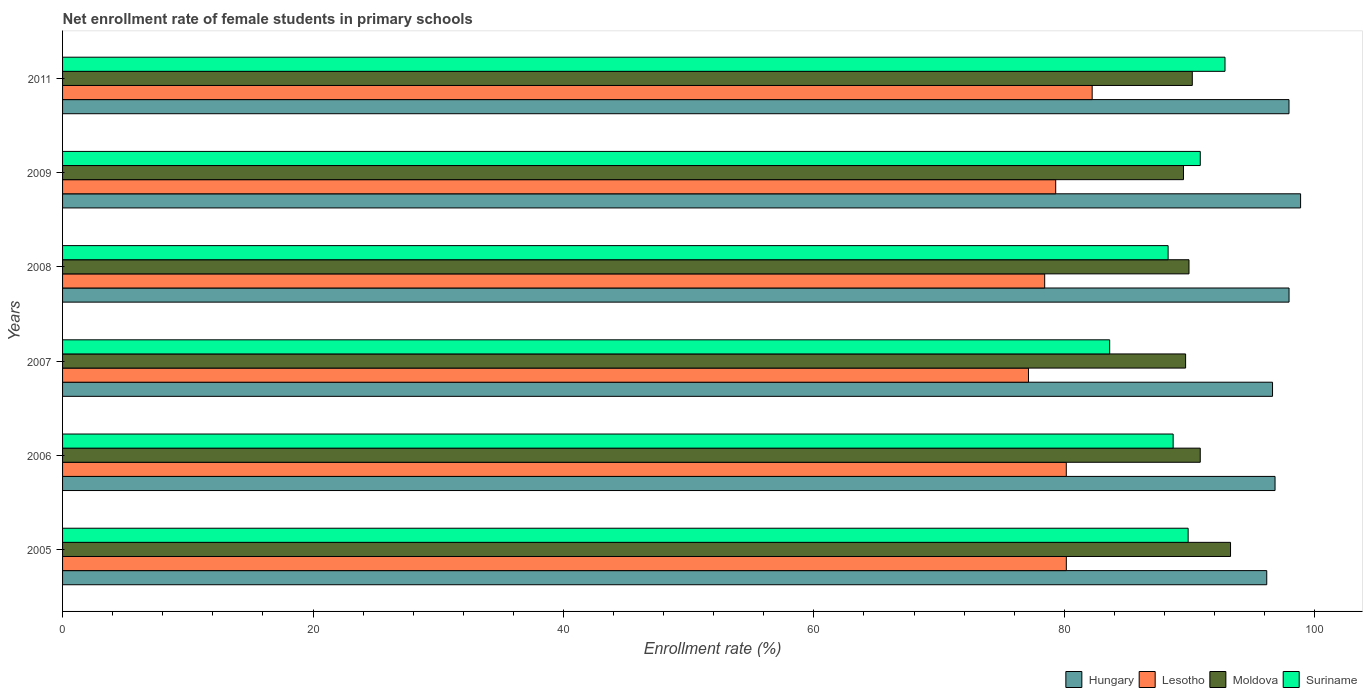Are the number of bars on each tick of the Y-axis equal?
Ensure brevity in your answer.  Yes. What is the label of the 6th group of bars from the top?
Provide a succinct answer. 2005. What is the net enrollment rate of female students in primary schools in Hungary in 2011?
Provide a succinct answer. 97.94. Across all years, what is the maximum net enrollment rate of female students in primary schools in Hungary?
Make the answer very short. 98.87. Across all years, what is the minimum net enrollment rate of female students in primary schools in Hungary?
Offer a very short reply. 96.17. What is the total net enrollment rate of female students in primary schools in Suriname in the graph?
Keep it short and to the point. 534.18. What is the difference between the net enrollment rate of female students in primary schools in Lesotho in 2008 and that in 2011?
Offer a terse response. -3.79. What is the difference between the net enrollment rate of female students in primary schools in Lesotho in 2009 and the net enrollment rate of female students in primary schools in Suriname in 2007?
Keep it short and to the point. -4.31. What is the average net enrollment rate of female students in primary schools in Moldova per year?
Offer a terse response. 90.58. In the year 2006, what is the difference between the net enrollment rate of female students in primary schools in Moldova and net enrollment rate of female students in primary schools in Suriname?
Provide a short and direct response. 2.16. What is the ratio of the net enrollment rate of female students in primary schools in Suriname in 2009 to that in 2011?
Give a very brief answer. 0.98. Is the net enrollment rate of female students in primary schools in Hungary in 2006 less than that in 2009?
Ensure brevity in your answer.  Yes. What is the difference between the highest and the second highest net enrollment rate of female students in primary schools in Lesotho?
Offer a very short reply. 2.06. What is the difference between the highest and the lowest net enrollment rate of female students in primary schools in Suriname?
Provide a succinct answer. 9.21. Is the sum of the net enrollment rate of female students in primary schools in Hungary in 2007 and 2011 greater than the maximum net enrollment rate of female students in primary schools in Lesotho across all years?
Provide a short and direct response. Yes. What does the 3rd bar from the top in 2005 represents?
Offer a terse response. Lesotho. What does the 4th bar from the bottom in 2009 represents?
Keep it short and to the point. Suriname. Is it the case that in every year, the sum of the net enrollment rate of female students in primary schools in Moldova and net enrollment rate of female students in primary schools in Hungary is greater than the net enrollment rate of female students in primary schools in Suriname?
Give a very brief answer. Yes. How many bars are there?
Your answer should be compact. 24. What is the difference between two consecutive major ticks on the X-axis?
Make the answer very short. 20. Are the values on the major ticks of X-axis written in scientific E-notation?
Offer a terse response. No. Where does the legend appear in the graph?
Provide a succinct answer. Bottom right. What is the title of the graph?
Provide a succinct answer. Net enrollment rate of female students in primary schools. What is the label or title of the X-axis?
Offer a terse response. Enrollment rate (%). What is the label or title of the Y-axis?
Keep it short and to the point. Years. What is the Enrollment rate (%) of Hungary in 2005?
Your answer should be compact. 96.17. What is the Enrollment rate (%) in Lesotho in 2005?
Ensure brevity in your answer.  80.16. What is the Enrollment rate (%) in Moldova in 2005?
Give a very brief answer. 93.27. What is the Enrollment rate (%) of Suriname in 2005?
Give a very brief answer. 89.89. What is the Enrollment rate (%) in Hungary in 2006?
Your answer should be very brief. 96.83. What is the Enrollment rate (%) of Lesotho in 2006?
Provide a short and direct response. 80.16. What is the Enrollment rate (%) in Moldova in 2006?
Your answer should be compact. 90.86. What is the Enrollment rate (%) in Suriname in 2006?
Provide a succinct answer. 88.69. What is the Enrollment rate (%) in Hungary in 2007?
Keep it short and to the point. 96.63. What is the Enrollment rate (%) in Lesotho in 2007?
Make the answer very short. 77.14. What is the Enrollment rate (%) of Moldova in 2007?
Your answer should be compact. 89.69. What is the Enrollment rate (%) of Suriname in 2007?
Ensure brevity in your answer.  83.62. What is the Enrollment rate (%) of Hungary in 2008?
Offer a terse response. 97.95. What is the Enrollment rate (%) of Lesotho in 2008?
Ensure brevity in your answer.  78.43. What is the Enrollment rate (%) in Moldova in 2008?
Ensure brevity in your answer.  89.96. What is the Enrollment rate (%) in Suriname in 2008?
Ensure brevity in your answer.  88.29. What is the Enrollment rate (%) of Hungary in 2009?
Keep it short and to the point. 98.87. What is the Enrollment rate (%) of Lesotho in 2009?
Ensure brevity in your answer.  79.31. What is the Enrollment rate (%) in Moldova in 2009?
Your answer should be very brief. 89.52. What is the Enrollment rate (%) of Suriname in 2009?
Keep it short and to the point. 90.86. What is the Enrollment rate (%) of Hungary in 2011?
Offer a very short reply. 97.94. What is the Enrollment rate (%) in Lesotho in 2011?
Your response must be concise. 82.22. What is the Enrollment rate (%) in Moldova in 2011?
Your response must be concise. 90.22. What is the Enrollment rate (%) of Suriname in 2011?
Keep it short and to the point. 92.83. Across all years, what is the maximum Enrollment rate (%) in Hungary?
Your answer should be compact. 98.87. Across all years, what is the maximum Enrollment rate (%) in Lesotho?
Make the answer very short. 82.22. Across all years, what is the maximum Enrollment rate (%) in Moldova?
Your answer should be very brief. 93.27. Across all years, what is the maximum Enrollment rate (%) of Suriname?
Give a very brief answer. 92.83. Across all years, what is the minimum Enrollment rate (%) of Hungary?
Ensure brevity in your answer.  96.17. Across all years, what is the minimum Enrollment rate (%) in Lesotho?
Provide a succinct answer. 77.14. Across all years, what is the minimum Enrollment rate (%) of Moldova?
Offer a terse response. 89.52. Across all years, what is the minimum Enrollment rate (%) of Suriname?
Offer a very short reply. 83.62. What is the total Enrollment rate (%) of Hungary in the graph?
Provide a succinct answer. 584.38. What is the total Enrollment rate (%) in Lesotho in the graph?
Make the answer very short. 477.42. What is the total Enrollment rate (%) of Moldova in the graph?
Offer a very short reply. 543.51. What is the total Enrollment rate (%) of Suriname in the graph?
Your answer should be very brief. 534.18. What is the difference between the Enrollment rate (%) in Hungary in 2005 and that in 2006?
Your response must be concise. -0.66. What is the difference between the Enrollment rate (%) of Lesotho in 2005 and that in 2006?
Your answer should be compact. 0. What is the difference between the Enrollment rate (%) of Moldova in 2005 and that in 2006?
Offer a terse response. 2.42. What is the difference between the Enrollment rate (%) in Suriname in 2005 and that in 2006?
Offer a terse response. 1.2. What is the difference between the Enrollment rate (%) in Hungary in 2005 and that in 2007?
Ensure brevity in your answer.  -0.46. What is the difference between the Enrollment rate (%) of Lesotho in 2005 and that in 2007?
Your answer should be very brief. 3.02. What is the difference between the Enrollment rate (%) of Moldova in 2005 and that in 2007?
Keep it short and to the point. 3.59. What is the difference between the Enrollment rate (%) in Suriname in 2005 and that in 2007?
Provide a short and direct response. 6.27. What is the difference between the Enrollment rate (%) of Hungary in 2005 and that in 2008?
Offer a terse response. -1.78. What is the difference between the Enrollment rate (%) of Lesotho in 2005 and that in 2008?
Your response must be concise. 1.73. What is the difference between the Enrollment rate (%) in Moldova in 2005 and that in 2008?
Your answer should be compact. 3.32. What is the difference between the Enrollment rate (%) of Suriname in 2005 and that in 2008?
Offer a terse response. 1.6. What is the difference between the Enrollment rate (%) of Hungary in 2005 and that in 2009?
Offer a very short reply. -2.7. What is the difference between the Enrollment rate (%) of Lesotho in 2005 and that in 2009?
Keep it short and to the point. 0.85. What is the difference between the Enrollment rate (%) of Moldova in 2005 and that in 2009?
Ensure brevity in your answer.  3.76. What is the difference between the Enrollment rate (%) of Suriname in 2005 and that in 2009?
Keep it short and to the point. -0.97. What is the difference between the Enrollment rate (%) of Hungary in 2005 and that in 2011?
Ensure brevity in your answer.  -1.78. What is the difference between the Enrollment rate (%) in Lesotho in 2005 and that in 2011?
Make the answer very short. -2.06. What is the difference between the Enrollment rate (%) in Moldova in 2005 and that in 2011?
Give a very brief answer. 3.05. What is the difference between the Enrollment rate (%) of Suriname in 2005 and that in 2011?
Provide a short and direct response. -2.94. What is the difference between the Enrollment rate (%) in Hungary in 2006 and that in 2007?
Provide a short and direct response. 0.2. What is the difference between the Enrollment rate (%) in Lesotho in 2006 and that in 2007?
Your response must be concise. 3.02. What is the difference between the Enrollment rate (%) of Moldova in 2006 and that in 2007?
Offer a terse response. 1.17. What is the difference between the Enrollment rate (%) of Suriname in 2006 and that in 2007?
Keep it short and to the point. 5.07. What is the difference between the Enrollment rate (%) in Hungary in 2006 and that in 2008?
Offer a very short reply. -1.12. What is the difference between the Enrollment rate (%) of Lesotho in 2006 and that in 2008?
Your answer should be very brief. 1.73. What is the difference between the Enrollment rate (%) in Moldova in 2006 and that in 2008?
Provide a short and direct response. 0.9. What is the difference between the Enrollment rate (%) of Suriname in 2006 and that in 2008?
Give a very brief answer. 0.4. What is the difference between the Enrollment rate (%) in Hungary in 2006 and that in 2009?
Your response must be concise. -2.04. What is the difference between the Enrollment rate (%) of Lesotho in 2006 and that in 2009?
Offer a terse response. 0.85. What is the difference between the Enrollment rate (%) of Moldova in 2006 and that in 2009?
Give a very brief answer. 1.34. What is the difference between the Enrollment rate (%) of Suriname in 2006 and that in 2009?
Make the answer very short. -2.17. What is the difference between the Enrollment rate (%) of Hungary in 2006 and that in 2011?
Give a very brief answer. -1.11. What is the difference between the Enrollment rate (%) of Lesotho in 2006 and that in 2011?
Make the answer very short. -2.07. What is the difference between the Enrollment rate (%) of Moldova in 2006 and that in 2011?
Your response must be concise. 0.64. What is the difference between the Enrollment rate (%) in Suriname in 2006 and that in 2011?
Make the answer very short. -4.14. What is the difference between the Enrollment rate (%) of Hungary in 2007 and that in 2008?
Keep it short and to the point. -1.32. What is the difference between the Enrollment rate (%) in Lesotho in 2007 and that in 2008?
Offer a very short reply. -1.29. What is the difference between the Enrollment rate (%) in Moldova in 2007 and that in 2008?
Your answer should be very brief. -0.27. What is the difference between the Enrollment rate (%) of Suriname in 2007 and that in 2008?
Make the answer very short. -4.67. What is the difference between the Enrollment rate (%) in Hungary in 2007 and that in 2009?
Your answer should be compact. -2.24. What is the difference between the Enrollment rate (%) in Lesotho in 2007 and that in 2009?
Your response must be concise. -2.17. What is the difference between the Enrollment rate (%) in Moldova in 2007 and that in 2009?
Provide a short and direct response. 0.17. What is the difference between the Enrollment rate (%) of Suriname in 2007 and that in 2009?
Provide a succinct answer. -7.24. What is the difference between the Enrollment rate (%) in Hungary in 2007 and that in 2011?
Offer a terse response. -1.32. What is the difference between the Enrollment rate (%) in Lesotho in 2007 and that in 2011?
Make the answer very short. -5.09. What is the difference between the Enrollment rate (%) of Moldova in 2007 and that in 2011?
Your answer should be compact. -0.53. What is the difference between the Enrollment rate (%) in Suriname in 2007 and that in 2011?
Your answer should be very brief. -9.21. What is the difference between the Enrollment rate (%) in Hungary in 2008 and that in 2009?
Provide a short and direct response. -0.92. What is the difference between the Enrollment rate (%) of Lesotho in 2008 and that in 2009?
Offer a terse response. -0.88. What is the difference between the Enrollment rate (%) in Moldova in 2008 and that in 2009?
Offer a terse response. 0.44. What is the difference between the Enrollment rate (%) of Suriname in 2008 and that in 2009?
Your answer should be compact. -2.57. What is the difference between the Enrollment rate (%) of Hungary in 2008 and that in 2011?
Provide a succinct answer. 0. What is the difference between the Enrollment rate (%) of Lesotho in 2008 and that in 2011?
Your answer should be very brief. -3.79. What is the difference between the Enrollment rate (%) in Moldova in 2008 and that in 2011?
Your answer should be compact. -0.26. What is the difference between the Enrollment rate (%) in Suriname in 2008 and that in 2011?
Provide a succinct answer. -4.54. What is the difference between the Enrollment rate (%) of Hungary in 2009 and that in 2011?
Offer a terse response. 0.93. What is the difference between the Enrollment rate (%) of Lesotho in 2009 and that in 2011?
Provide a succinct answer. -2.91. What is the difference between the Enrollment rate (%) of Moldova in 2009 and that in 2011?
Ensure brevity in your answer.  -0.7. What is the difference between the Enrollment rate (%) in Suriname in 2009 and that in 2011?
Ensure brevity in your answer.  -1.98. What is the difference between the Enrollment rate (%) in Hungary in 2005 and the Enrollment rate (%) in Lesotho in 2006?
Your answer should be very brief. 16.01. What is the difference between the Enrollment rate (%) of Hungary in 2005 and the Enrollment rate (%) of Moldova in 2006?
Keep it short and to the point. 5.31. What is the difference between the Enrollment rate (%) in Hungary in 2005 and the Enrollment rate (%) in Suriname in 2006?
Provide a short and direct response. 7.48. What is the difference between the Enrollment rate (%) in Lesotho in 2005 and the Enrollment rate (%) in Moldova in 2006?
Your response must be concise. -10.69. What is the difference between the Enrollment rate (%) of Lesotho in 2005 and the Enrollment rate (%) of Suriname in 2006?
Your answer should be very brief. -8.53. What is the difference between the Enrollment rate (%) in Moldova in 2005 and the Enrollment rate (%) in Suriname in 2006?
Your answer should be compact. 4.58. What is the difference between the Enrollment rate (%) in Hungary in 2005 and the Enrollment rate (%) in Lesotho in 2007?
Your answer should be very brief. 19.03. What is the difference between the Enrollment rate (%) of Hungary in 2005 and the Enrollment rate (%) of Moldova in 2007?
Your response must be concise. 6.48. What is the difference between the Enrollment rate (%) in Hungary in 2005 and the Enrollment rate (%) in Suriname in 2007?
Offer a terse response. 12.55. What is the difference between the Enrollment rate (%) in Lesotho in 2005 and the Enrollment rate (%) in Moldova in 2007?
Provide a short and direct response. -9.53. What is the difference between the Enrollment rate (%) of Lesotho in 2005 and the Enrollment rate (%) of Suriname in 2007?
Keep it short and to the point. -3.46. What is the difference between the Enrollment rate (%) of Moldova in 2005 and the Enrollment rate (%) of Suriname in 2007?
Give a very brief answer. 9.65. What is the difference between the Enrollment rate (%) in Hungary in 2005 and the Enrollment rate (%) in Lesotho in 2008?
Your response must be concise. 17.73. What is the difference between the Enrollment rate (%) of Hungary in 2005 and the Enrollment rate (%) of Moldova in 2008?
Provide a short and direct response. 6.21. What is the difference between the Enrollment rate (%) of Hungary in 2005 and the Enrollment rate (%) of Suriname in 2008?
Provide a succinct answer. 7.88. What is the difference between the Enrollment rate (%) in Lesotho in 2005 and the Enrollment rate (%) in Moldova in 2008?
Keep it short and to the point. -9.8. What is the difference between the Enrollment rate (%) of Lesotho in 2005 and the Enrollment rate (%) of Suriname in 2008?
Keep it short and to the point. -8.13. What is the difference between the Enrollment rate (%) of Moldova in 2005 and the Enrollment rate (%) of Suriname in 2008?
Offer a terse response. 4.99. What is the difference between the Enrollment rate (%) in Hungary in 2005 and the Enrollment rate (%) in Lesotho in 2009?
Offer a terse response. 16.85. What is the difference between the Enrollment rate (%) in Hungary in 2005 and the Enrollment rate (%) in Moldova in 2009?
Provide a succinct answer. 6.65. What is the difference between the Enrollment rate (%) of Hungary in 2005 and the Enrollment rate (%) of Suriname in 2009?
Keep it short and to the point. 5.31. What is the difference between the Enrollment rate (%) in Lesotho in 2005 and the Enrollment rate (%) in Moldova in 2009?
Your answer should be very brief. -9.36. What is the difference between the Enrollment rate (%) in Lesotho in 2005 and the Enrollment rate (%) in Suriname in 2009?
Your answer should be compact. -10.7. What is the difference between the Enrollment rate (%) in Moldova in 2005 and the Enrollment rate (%) in Suriname in 2009?
Your answer should be compact. 2.42. What is the difference between the Enrollment rate (%) in Hungary in 2005 and the Enrollment rate (%) in Lesotho in 2011?
Your answer should be very brief. 13.94. What is the difference between the Enrollment rate (%) in Hungary in 2005 and the Enrollment rate (%) in Moldova in 2011?
Ensure brevity in your answer.  5.95. What is the difference between the Enrollment rate (%) of Hungary in 2005 and the Enrollment rate (%) of Suriname in 2011?
Offer a very short reply. 3.33. What is the difference between the Enrollment rate (%) in Lesotho in 2005 and the Enrollment rate (%) in Moldova in 2011?
Your answer should be compact. -10.06. What is the difference between the Enrollment rate (%) in Lesotho in 2005 and the Enrollment rate (%) in Suriname in 2011?
Provide a succinct answer. -12.67. What is the difference between the Enrollment rate (%) of Moldova in 2005 and the Enrollment rate (%) of Suriname in 2011?
Offer a very short reply. 0.44. What is the difference between the Enrollment rate (%) of Hungary in 2006 and the Enrollment rate (%) of Lesotho in 2007?
Provide a short and direct response. 19.69. What is the difference between the Enrollment rate (%) of Hungary in 2006 and the Enrollment rate (%) of Moldova in 2007?
Your answer should be very brief. 7.14. What is the difference between the Enrollment rate (%) in Hungary in 2006 and the Enrollment rate (%) in Suriname in 2007?
Offer a very short reply. 13.21. What is the difference between the Enrollment rate (%) of Lesotho in 2006 and the Enrollment rate (%) of Moldova in 2007?
Offer a terse response. -9.53. What is the difference between the Enrollment rate (%) in Lesotho in 2006 and the Enrollment rate (%) in Suriname in 2007?
Keep it short and to the point. -3.46. What is the difference between the Enrollment rate (%) in Moldova in 2006 and the Enrollment rate (%) in Suriname in 2007?
Give a very brief answer. 7.23. What is the difference between the Enrollment rate (%) in Hungary in 2006 and the Enrollment rate (%) in Lesotho in 2008?
Provide a short and direct response. 18.4. What is the difference between the Enrollment rate (%) of Hungary in 2006 and the Enrollment rate (%) of Moldova in 2008?
Your response must be concise. 6.87. What is the difference between the Enrollment rate (%) in Hungary in 2006 and the Enrollment rate (%) in Suriname in 2008?
Offer a very short reply. 8.54. What is the difference between the Enrollment rate (%) of Lesotho in 2006 and the Enrollment rate (%) of Moldova in 2008?
Your answer should be compact. -9.8. What is the difference between the Enrollment rate (%) of Lesotho in 2006 and the Enrollment rate (%) of Suriname in 2008?
Give a very brief answer. -8.13. What is the difference between the Enrollment rate (%) of Moldova in 2006 and the Enrollment rate (%) of Suriname in 2008?
Keep it short and to the point. 2.57. What is the difference between the Enrollment rate (%) in Hungary in 2006 and the Enrollment rate (%) in Lesotho in 2009?
Provide a succinct answer. 17.52. What is the difference between the Enrollment rate (%) of Hungary in 2006 and the Enrollment rate (%) of Moldova in 2009?
Ensure brevity in your answer.  7.31. What is the difference between the Enrollment rate (%) in Hungary in 2006 and the Enrollment rate (%) in Suriname in 2009?
Give a very brief answer. 5.97. What is the difference between the Enrollment rate (%) in Lesotho in 2006 and the Enrollment rate (%) in Moldova in 2009?
Ensure brevity in your answer.  -9.36. What is the difference between the Enrollment rate (%) of Lesotho in 2006 and the Enrollment rate (%) of Suriname in 2009?
Provide a succinct answer. -10.7. What is the difference between the Enrollment rate (%) in Moldova in 2006 and the Enrollment rate (%) in Suriname in 2009?
Offer a terse response. -0. What is the difference between the Enrollment rate (%) of Hungary in 2006 and the Enrollment rate (%) of Lesotho in 2011?
Your answer should be very brief. 14.6. What is the difference between the Enrollment rate (%) of Hungary in 2006 and the Enrollment rate (%) of Moldova in 2011?
Give a very brief answer. 6.61. What is the difference between the Enrollment rate (%) of Hungary in 2006 and the Enrollment rate (%) of Suriname in 2011?
Offer a very short reply. 4. What is the difference between the Enrollment rate (%) in Lesotho in 2006 and the Enrollment rate (%) in Moldova in 2011?
Offer a terse response. -10.06. What is the difference between the Enrollment rate (%) of Lesotho in 2006 and the Enrollment rate (%) of Suriname in 2011?
Offer a very short reply. -12.67. What is the difference between the Enrollment rate (%) of Moldova in 2006 and the Enrollment rate (%) of Suriname in 2011?
Offer a terse response. -1.98. What is the difference between the Enrollment rate (%) in Hungary in 2007 and the Enrollment rate (%) in Lesotho in 2008?
Your response must be concise. 18.2. What is the difference between the Enrollment rate (%) in Hungary in 2007 and the Enrollment rate (%) in Moldova in 2008?
Your answer should be compact. 6.67. What is the difference between the Enrollment rate (%) of Hungary in 2007 and the Enrollment rate (%) of Suriname in 2008?
Your response must be concise. 8.34. What is the difference between the Enrollment rate (%) in Lesotho in 2007 and the Enrollment rate (%) in Moldova in 2008?
Your answer should be very brief. -12.82. What is the difference between the Enrollment rate (%) in Lesotho in 2007 and the Enrollment rate (%) in Suriname in 2008?
Make the answer very short. -11.15. What is the difference between the Enrollment rate (%) of Moldova in 2007 and the Enrollment rate (%) of Suriname in 2008?
Your response must be concise. 1.4. What is the difference between the Enrollment rate (%) of Hungary in 2007 and the Enrollment rate (%) of Lesotho in 2009?
Ensure brevity in your answer.  17.32. What is the difference between the Enrollment rate (%) of Hungary in 2007 and the Enrollment rate (%) of Moldova in 2009?
Keep it short and to the point. 7.11. What is the difference between the Enrollment rate (%) of Hungary in 2007 and the Enrollment rate (%) of Suriname in 2009?
Provide a succinct answer. 5.77. What is the difference between the Enrollment rate (%) of Lesotho in 2007 and the Enrollment rate (%) of Moldova in 2009?
Give a very brief answer. -12.38. What is the difference between the Enrollment rate (%) of Lesotho in 2007 and the Enrollment rate (%) of Suriname in 2009?
Your answer should be very brief. -13.72. What is the difference between the Enrollment rate (%) in Moldova in 2007 and the Enrollment rate (%) in Suriname in 2009?
Give a very brief answer. -1.17. What is the difference between the Enrollment rate (%) of Hungary in 2007 and the Enrollment rate (%) of Lesotho in 2011?
Keep it short and to the point. 14.4. What is the difference between the Enrollment rate (%) of Hungary in 2007 and the Enrollment rate (%) of Moldova in 2011?
Keep it short and to the point. 6.41. What is the difference between the Enrollment rate (%) in Hungary in 2007 and the Enrollment rate (%) in Suriname in 2011?
Make the answer very short. 3.8. What is the difference between the Enrollment rate (%) in Lesotho in 2007 and the Enrollment rate (%) in Moldova in 2011?
Your answer should be compact. -13.08. What is the difference between the Enrollment rate (%) of Lesotho in 2007 and the Enrollment rate (%) of Suriname in 2011?
Keep it short and to the point. -15.69. What is the difference between the Enrollment rate (%) in Moldova in 2007 and the Enrollment rate (%) in Suriname in 2011?
Provide a succinct answer. -3.15. What is the difference between the Enrollment rate (%) of Hungary in 2008 and the Enrollment rate (%) of Lesotho in 2009?
Make the answer very short. 18.63. What is the difference between the Enrollment rate (%) of Hungary in 2008 and the Enrollment rate (%) of Moldova in 2009?
Provide a short and direct response. 8.43. What is the difference between the Enrollment rate (%) in Hungary in 2008 and the Enrollment rate (%) in Suriname in 2009?
Ensure brevity in your answer.  7.09. What is the difference between the Enrollment rate (%) of Lesotho in 2008 and the Enrollment rate (%) of Moldova in 2009?
Offer a very short reply. -11.08. What is the difference between the Enrollment rate (%) of Lesotho in 2008 and the Enrollment rate (%) of Suriname in 2009?
Your answer should be very brief. -12.43. What is the difference between the Enrollment rate (%) of Moldova in 2008 and the Enrollment rate (%) of Suriname in 2009?
Keep it short and to the point. -0.9. What is the difference between the Enrollment rate (%) of Hungary in 2008 and the Enrollment rate (%) of Lesotho in 2011?
Provide a short and direct response. 15.72. What is the difference between the Enrollment rate (%) of Hungary in 2008 and the Enrollment rate (%) of Moldova in 2011?
Your response must be concise. 7.73. What is the difference between the Enrollment rate (%) of Hungary in 2008 and the Enrollment rate (%) of Suriname in 2011?
Make the answer very short. 5.11. What is the difference between the Enrollment rate (%) in Lesotho in 2008 and the Enrollment rate (%) in Moldova in 2011?
Provide a short and direct response. -11.79. What is the difference between the Enrollment rate (%) in Lesotho in 2008 and the Enrollment rate (%) in Suriname in 2011?
Make the answer very short. -14.4. What is the difference between the Enrollment rate (%) of Moldova in 2008 and the Enrollment rate (%) of Suriname in 2011?
Provide a short and direct response. -2.88. What is the difference between the Enrollment rate (%) in Hungary in 2009 and the Enrollment rate (%) in Lesotho in 2011?
Make the answer very short. 16.64. What is the difference between the Enrollment rate (%) of Hungary in 2009 and the Enrollment rate (%) of Moldova in 2011?
Provide a short and direct response. 8.65. What is the difference between the Enrollment rate (%) in Hungary in 2009 and the Enrollment rate (%) in Suriname in 2011?
Offer a terse response. 6.04. What is the difference between the Enrollment rate (%) of Lesotho in 2009 and the Enrollment rate (%) of Moldova in 2011?
Ensure brevity in your answer.  -10.91. What is the difference between the Enrollment rate (%) in Lesotho in 2009 and the Enrollment rate (%) in Suriname in 2011?
Offer a very short reply. -13.52. What is the difference between the Enrollment rate (%) of Moldova in 2009 and the Enrollment rate (%) of Suriname in 2011?
Offer a terse response. -3.32. What is the average Enrollment rate (%) in Hungary per year?
Provide a short and direct response. 97.4. What is the average Enrollment rate (%) in Lesotho per year?
Ensure brevity in your answer.  79.57. What is the average Enrollment rate (%) of Moldova per year?
Ensure brevity in your answer.  90.58. What is the average Enrollment rate (%) in Suriname per year?
Offer a very short reply. 89.03. In the year 2005, what is the difference between the Enrollment rate (%) of Hungary and Enrollment rate (%) of Lesotho?
Keep it short and to the point. 16.01. In the year 2005, what is the difference between the Enrollment rate (%) of Hungary and Enrollment rate (%) of Moldova?
Offer a terse response. 2.89. In the year 2005, what is the difference between the Enrollment rate (%) in Hungary and Enrollment rate (%) in Suriname?
Provide a succinct answer. 6.28. In the year 2005, what is the difference between the Enrollment rate (%) in Lesotho and Enrollment rate (%) in Moldova?
Provide a short and direct response. -13.11. In the year 2005, what is the difference between the Enrollment rate (%) of Lesotho and Enrollment rate (%) of Suriname?
Keep it short and to the point. -9.73. In the year 2005, what is the difference between the Enrollment rate (%) in Moldova and Enrollment rate (%) in Suriname?
Your answer should be very brief. 3.39. In the year 2006, what is the difference between the Enrollment rate (%) in Hungary and Enrollment rate (%) in Lesotho?
Give a very brief answer. 16.67. In the year 2006, what is the difference between the Enrollment rate (%) of Hungary and Enrollment rate (%) of Moldova?
Offer a very short reply. 5.97. In the year 2006, what is the difference between the Enrollment rate (%) of Hungary and Enrollment rate (%) of Suriname?
Make the answer very short. 8.14. In the year 2006, what is the difference between the Enrollment rate (%) in Lesotho and Enrollment rate (%) in Moldova?
Your answer should be compact. -10.7. In the year 2006, what is the difference between the Enrollment rate (%) of Lesotho and Enrollment rate (%) of Suriname?
Your response must be concise. -8.53. In the year 2006, what is the difference between the Enrollment rate (%) in Moldova and Enrollment rate (%) in Suriname?
Give a very brief answer. 2.16. In the year 2007, what is the difference between the Enrollment rate (%) in Hungary and Enrollment rate (%) in Lesotho?
Provide a succinct answer. 19.49. In the year 2007, what is the difference between the Enrollment rate (%) in Hungary and Enrollment rate (%) in Moldova?
Your answer should be compact. 6.94. In the year 2007, what is the difference between the Enrollment rate (%) of Hungary and Enrollment rate (%) of Suriname?
Keep it short and to the point. 13.01. In the year 2007, what is the difference between the Enrollment rate (%) in Lesotho and Enrollment rate (%) in Moldova?
Your answer should be compact. -12.55. In the year 2007, what is the difference between the Enrollment rate (%) in Lesotho and Enrollment rate (%) in Suriname?
Ensure brevity in your answer.  -6.48. In the year 2007, what is the difference between the Enrollment rate (%) of Moldova and Enrollment rate (%) of Suriname?
Your answer should be very brief. 6.06. In the year 2008, what is the difference between the Enrollment rate (%) of Hungary and Enrollment rate (%) of Lesotho?
Ensure brevity in your answer.  19.52. In the year 2008, what is the difference between the Enrollment rate (%) in Hungary and Enrollment rate (%) in Moldova?
Provide a succinct answer. 7.99. In the year 2008, what is the difference between the Enrollment rate (%) of Hungary and Enrollment rate (%) of Suriname?
Offer a terse response. 9.66. In the year 2008, what is the difference between the Enrollment rate (%) in Lesotho and Enrollment rate (%) in Moldova?
Keep it short and to the point. -11.52. In the year 2008, what is the difference between the Enrollment rate (%) in Lesotho and Enrollment rate (%) in Suriname?
Ensure brevity in your answer.  -9.86. In the year 2008, what is the difference between the Enrollment rate (%) of Moldova and Enrollment rate (%) of Suriname?
Provide a succinct answer. 1.67. In the year 2009, what is the difference between the Enrollment rate (%) in Hungary and Enrollment rate (%) in Lesotho?
Your response must be concise. 19.56. In the year 2009, what is the difference between the Enrollment rate (%) of Hungary and Enrollment rate (%) of Moldova?
Your response must be concise. 9.35. In the year 2009, what is the difference between the Enrollment rate (%) of Hungary and Enrollment rate (%) of Suriname?
Keep it short and to the point. 8.01. In the year 2009, what is the difference between the Enrollment rate (%) of Lesotho and Enrollment rate (%) of Moldova?
Keep it short and to the point. -10.2. In the year 2009, what is the difference between the Enrollment rate (%) of Lesotho and Enrollment rate (%) of Suriname?
Your answer should be very brief. -11.54. In the year 2009, what is the difference between the Enrollment rate (%) of Moldova and Enrollment rate (%) of Suriname?
Provide a short and direct response. -1.34. In the year 2011, what is the difference between the Enrollment rate (%) in Hungary and Enrollment rate (%) in Lesotho?
Your answer should be compact. 15.72. In the year 2011, what is the difference between the Enrollment rate (%) of Hungary and Enrollment rate (%) of Moldova?
Give a very brief answer. 7.72. In the year 2011, what is the difference between the Enrollment rate (%) in Hungary and Enrollment rate (%) in Suriname?
Your answer should be very brief. 5.11. In the year 2011, what is the difference between the Enrollment rate (%) in Lesotho and Enrollment rate (%) in Moldova?
Your answer should be very brief. -8. In the year 2011, what is the difference between the Enrollment rate (%) in Lesotho and Enrollment rate (%) in Suriname?
Provide a succinct answer. -10.61. In the year 2011, what is the difference between the Enrollment rate (%) in Moldova and Enrollment rate (%) in Suriname?
Provide a succinct answer. -2.61. What is the ratio of the Enrollment rate (%) in Hungary in 2005 to that in 2006?
Provide a short and direct response. 0.99. What is the ratio of the Enrollment rate (%) of Moldova in 2005 to that in 2006?
Make the answer very short. 1.03. What is the ratio of the Enrollment rate (%) of Suriname in 2005 to that in 2006?
Provide a succinct answer. 1.01. What is the ratio of the Enrollment rate (%) of Lesotho in 2005 to that in 2007?
Ensure brevity in your answer.  1.04. What is the ratio of the Enrollment rate (%) of Moldova in 2005 to that in 2007?
Keep it short and to the point. 1.04. What is the ratio of the Enrollment rate (%) in Suriname in 2005 to that in 2007?
Your answer should be compact. 1.07. What is the ratio of the Enrollment rate (%) of Hungary in 2005 to that in 2008?
Give a very brief answer. 0.98. What is the ratio of the Enrollment rate (%) of Lesotho in 2005 to that in 2008?
Make the answer very short. 1.02. What is the ratio of the Enrollment rate (%) in Moldova in 2005 to that in 2008?
Provide a succinct answer. 1.04. What is the ratio of the Enrollment rate (%) of Suriname in 2005 to that in 2008?
Your response must be concise. 1.02. What is the ratio of the Enrollment rate (%) in Hungary in 2005 to that in 2009?
Provide a succinct answer. 0.97. What is the ratio of the Enrollment rate (%) in Lesotho in 2005 to that in 2009?
Your answer should be very brief. 1.01. What is the ratio of the Enrollment rate (%) of Moldova in 2005 to that in 2009?
Offer a terse response. 1.04. What is the ratio of the Enrollment rate (%) of Suriname in 2005 to that in 2009?
Give a very brief answer. 0.99. What is the ratio of the Enrollment rate (%) of Hungary in 2005 to that in 2011?
Offer a very short reply. 0.98. What is the ratio of the Enrollment rate (%) in Lesotho in 2005 to that in 2011?
Ensure brevity in your answer.  0.97. What is the ratio of the Enrollment rate (%) in Moldova in 2005 to that in 2011?
Keep it short and to the point. 1.03. What is the ratio of the Enrollment rate (%) in Suriname in 2005 to that in 2011?
Offer a terse response. 0.97. What is the ratio of the Enrollment rate (%) of Lesotho in 2006 to that in 2007?
Give a very brief answer. 1.04. What is the ratio of the Enrollment rate (%) of Moldova in 2006 to that in 2007?
Provide a short and direct response. 1.01. What is the ratio of the Enrollment rate (%) in Suriname in 2006 to that in 2007?
Offer a very short reply. 1.06. What is the ratio of the Enrollment rate (%) of Lesotho in 2006 to that in 2008?
Give a very brief answer. 1.02. What is the ratio of the Enrollment rate (%) in Suriname in 2006 to that in 2008?
Offer a terse response. 1. What is the ratio of the Enrollment rate (%) of Hungary in 2006 to that in 2009?
Offer a terse response. 0.98. What is the ratio of the Enrollment rate (%) of Lesotho in 2006 to that in 2009?
Your response must be concise. 1.01. What is the ratio of the Enrollment rate (%) in Suriname in 2006 to that in 2009?
Ensure brevity in your answer.  0.98. What is the ratio of the Enrollment rate (%) in Hungary in 2006 to that in 2011?
Keep it short and to the point. 0.99. What is the ratio of the Enrollment rate (%) in Lesotho in 2006 to that in 2011?
Keep it short and to the point. 0.97. What is the ratio of the Enrollment rate (%) in Suriname in 2006 to that in 2011?
Offer a terse response. 0.96. What is the ratio of the Enrollment rate (%) in Hungary in 2007 to that in 2008?
Make the answer very short. 0.99. What is the ratio of the Enrollment rate (%) of Lesotho in 2007 to that in 2008?
Provide a succinct answer. 0.98. What is the ratio of the Enrollment rate (%) in Suriname in 2007 to that in 2008?
Provide a succinct answer. 0.95. What is the ratio of the Enrollment rate (%) of Hungary in 2007 to that in 2009?
Offer a very short reply. 0.98. What is the ratio of the Enrollment rate (%) in Lesotho in 2007 to that in 2009?
Your answer should be compact. 0.97. What is the ratio of the Enrollment rate (%) of Moldova in 2007 to that in 2009?
Give a very brief answer. 1. What is the ratio of the Enrollment rate (%) in Suriname in 2007 to that in 2009?
Offer a terse response. 0.92. What is the ratio of the Enrollment rate (%) of Hungary in 2007 to that in 2011?
Give a very brief answer. 0.99. What is the ratio of the Enrollment rate (%) of Lesotho in 2007 to that in 2011?
Provide a succinct answer. 0.94. What is the ratio of the Enrollment rate (%) in Suriname in 2007 to that in 2011?
Provide a succinct answer. 0.9. What is the ratio of the Enrollment rate (%) of Lesotho in 2008 to that in 2009?
Your answer should be very brief. 0.99. What is the ratio of the Enrollment rate (%) in Suriname in 2008 to that in 2009?
Your answer should be compact. 0.97. What is the ratio of the Enrollment rate (%) in Hungary in 2008 to that in 2011?
Make the answer very short. 1. What is the ratio of the Enrollment rate (%) in Lesotho in 2008 to that in 2011?
Keep it short and to the point. 0.95. What is the ratio of the Enrollment rate (%) of Moldova in 2008 to that in 2011?
Keep it short and to the point. 1. What is the ratio of the Enrollment rate (%) in Suriname in 2008 to that in 2011?
Give a very brief answer. 0.95. What is the ratio of the Enrollment rate (%) in Hungary in 2009 to that in 2011?
Make the answer very short. 1.01. What is the ratio of the Enrollment rate (%) of Lesotho in 2009 to that in 2011?
Provide a short and direct response. 0.96. What is the ratio of the Enrollment rate (%) of Suriname in 2009 to that in 2011?
Keep it short and to the point. 0.98. What is the difference between the highest and the second highest Enrollment rate (%) in Hungary?
Your response must be concise. 0.92. What is the difference between the highest and the second highest Enrollment rate (%) of Lesotho?
Offer a very short reply. 2.06. What is the difference between the highest and the second highest Enrollment rate (%) of Moldova?
Keep it short and to the point. 2.42. What is the difference between the highest and the second highest Enrollment rate (%) of Suriname?
Your answer should be compact. 1.98. What is the difference between the highest and the lowest Enrollment rate (%) of Hungary?
Ensure brevity in your answer.  2.7. What is the difference between the highest and the lowest Enrollment rate (%) of Lesotho?
Ensure brevity in your answer.  5.09. What is the difference between the highest and the lowest Enrollment rate (%) in Moldova?
Give a very brief answer. 3.76. What is the difference between the highest and the lowest Enrollment rate (%) of Suriname?
Ensure brevity in your answer.  9.21. 